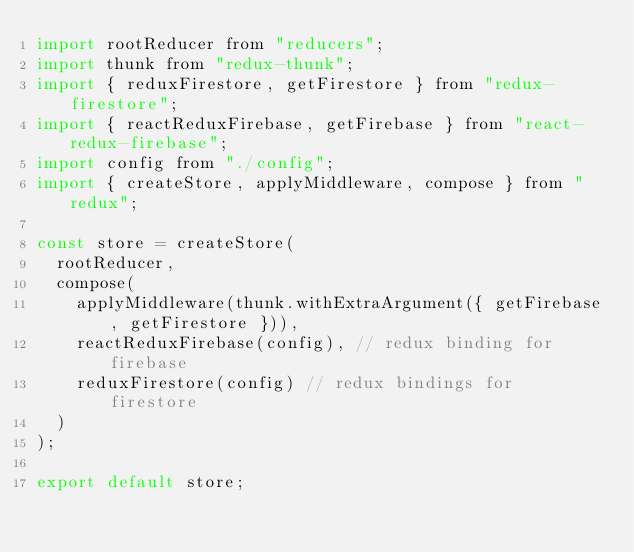<code> <loc_0><loc_0><loc_500><loc_500><_JavaScript_>import rootReducer from "reducers";
import thunk from "redux-thunk";
import { reduxFirestore, getFirestore } from "redux-firestore";
import { reactReduxFirebase, getFirebase } from "react-redux-firebase";
import config from "./config";
import { createStore, applyMiddleware, compose } from "redux";

const store = createStore(
  rootReducer,
  compose(
    applyMiddleware(thunk.withExtraArgument({ getFirebase, getFirestore })),
    reactReduxFirebase(config), // redux binding for firebase
    reduxFirestore(config) // redux bindings for firestore
  )
);

export default store;
</code> 